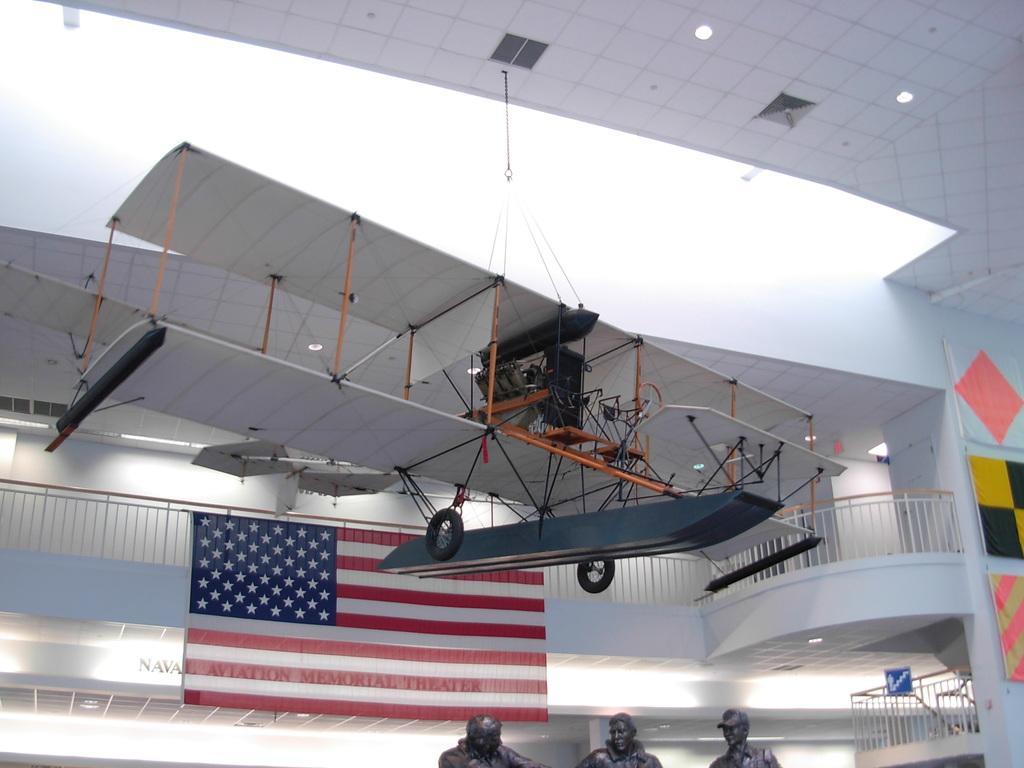In one or two sentences, can you explain what this image depicts? At the bottom I can see three persons statues, fence, flags and a wall. At the top I can see a vehicle is hanged on a rooftop and lights. This image is taken may be in a hall. 